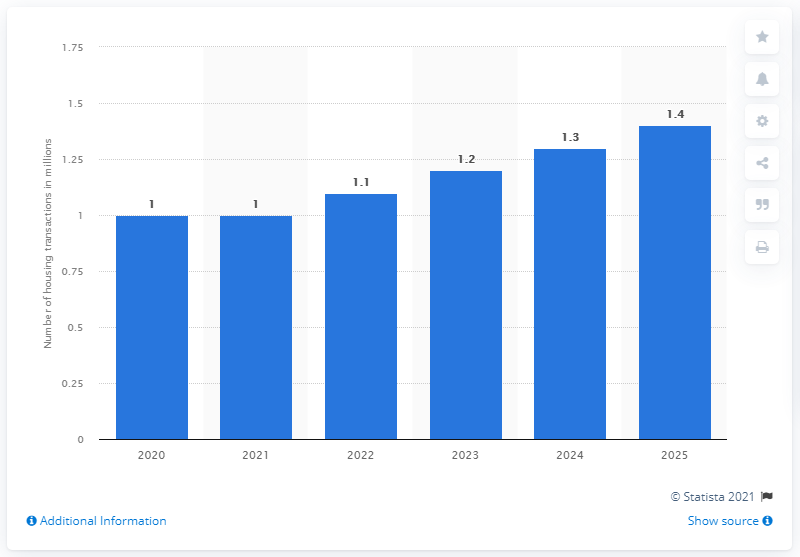Indicate a few pertinent items in this graphic. It is forecasted that 1.4 housing transactions will occur in 2025. 